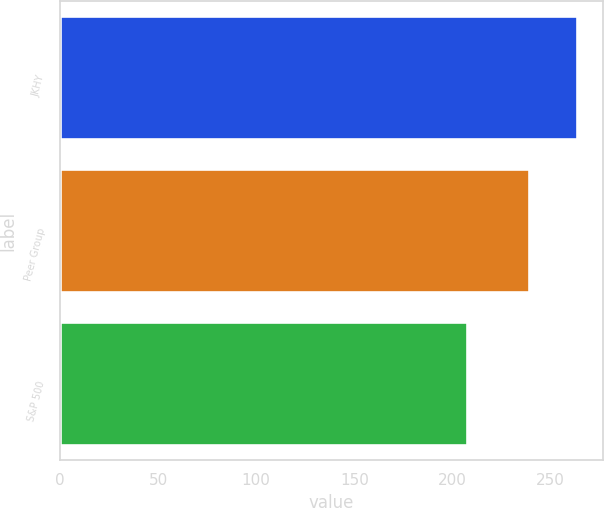Convert chart. <chart><loc_0><loc_0><loc_500><loc_500><bar_chart><fcel>JKHY<fcel>Peer Group<fcel>S&P 500<nl><fcel>263.21<fcel>239.1<fcel>207.1<nl></chart> 